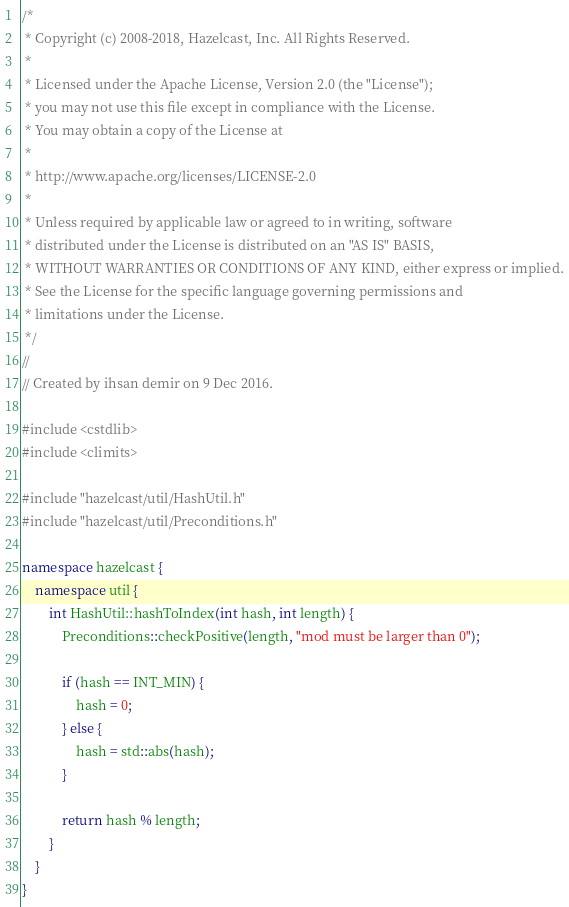<code> <loc_0><loc_0><loc_500><loc_500><_C++_>/*
 * Copyright (c) 2008-2018, Hazelcast, Inc. All Rights Reserved.
 *
 * Licensed under the Apache License, Version 2.0 (the "License");
 * you may not use this file except in compliance with the License.
 * You may obtain a copy of the License at
 *
 * http://www.apache.org/licenses/LICENSE-2.0
 *
 * Unless required by applicable law or agreed to in writing, software
 * distributed under the License is distributed on an "AS IS" BASIS,
 * WITHOUT WARRANTIES OR CONDITIONS OF ANY KIND, either express or implied.
 * See the License for the specific language governing permissions and
 * limitations under the License.
 */
//
// Created by ihsan demir on 9 Dec 2016.

#include <cstdlib>
#include <climits>

#include "hazelcast/util/HashUtil.h"
#include "hazelcast/util/Preconditions.h"

namespace hazelcast {
    namespace util {
        int HashUtil::hashToIndex(int hash, int length) {
            Preconditions::checkPositive(length, "mod must be larger than 0");

            if (hash == INT_MIN) {
                hash = 0;
            } else {
                hash = std::abs(hash);
            }

            return hash % length;
        }
    }
}


</code> 